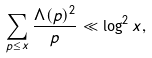Convert formula to latex. <formula><loc_0><loc_0><loc_500><loc_500>\sum _ { p \leq x } \frac { \Lambda ( p ) ^ { 2 } } { p } \ll \log ^ { 2 } x ,</formula> 